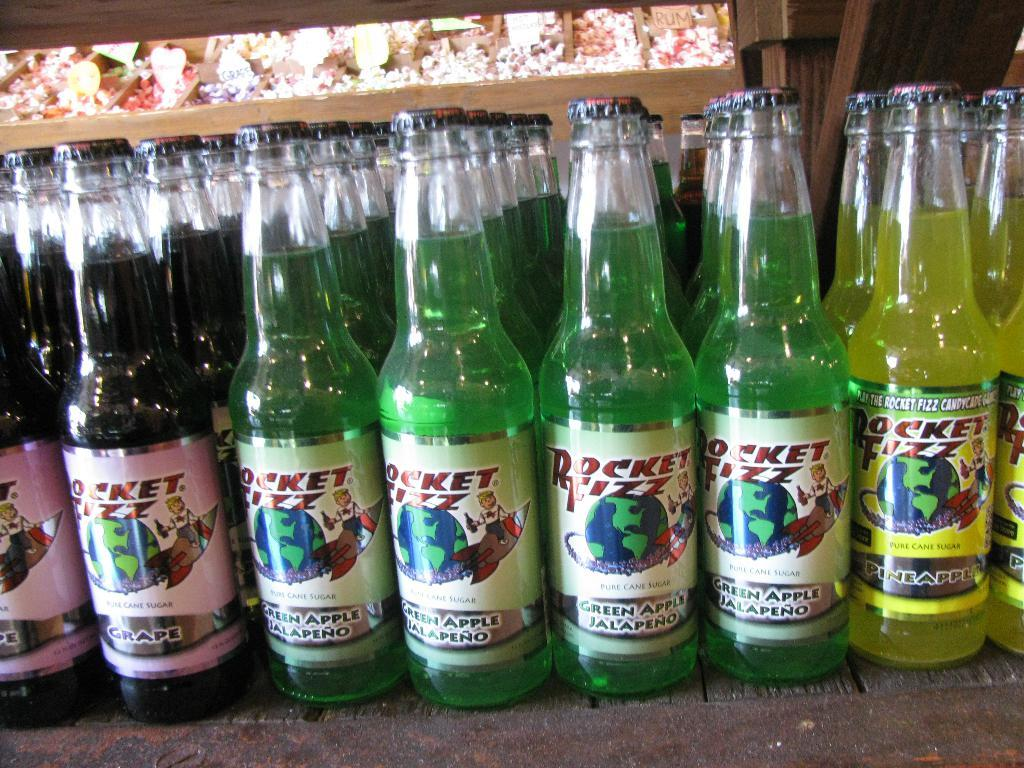What objects are present in the image? There are several bottles in the image. What are the bottles containing? The bottles contain different liquids. How many friends are sitting on the spade in the image? There are no friends or spades present in the image; it only contains bottles with different liquids. 